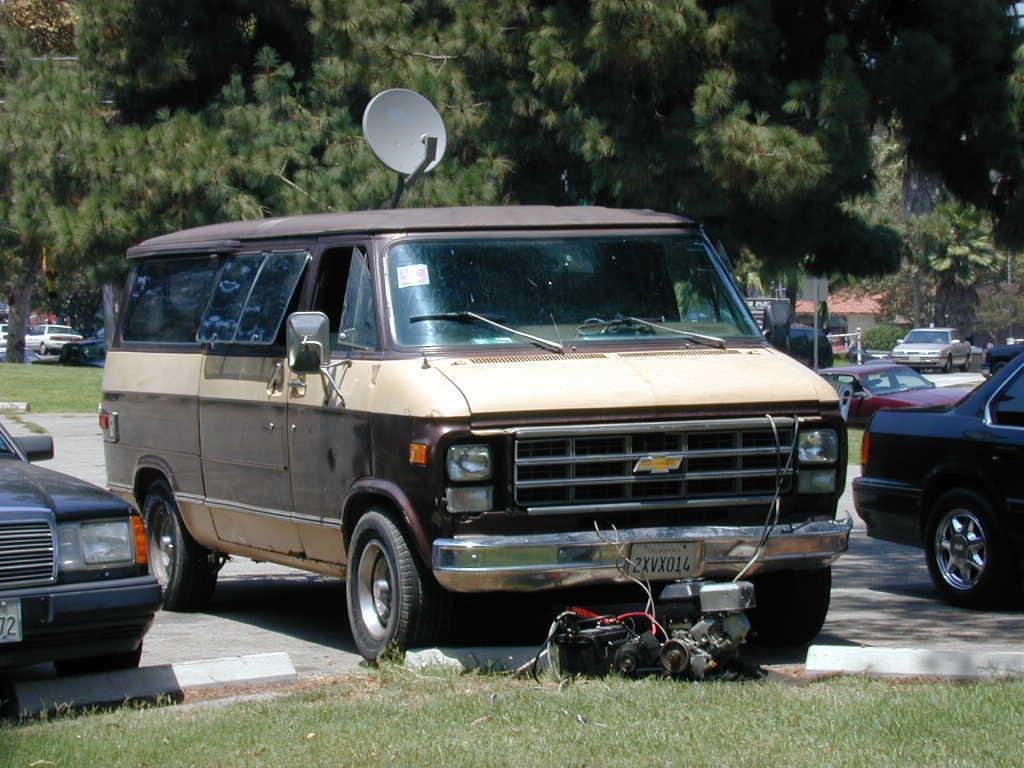Can you describe this image briefly? This is an outside view. In this image I can see many vehicles on the road. Here I can see an antenna at the top of a vehicle. At the bottom, I can see the grass. In the background there are many trees. 